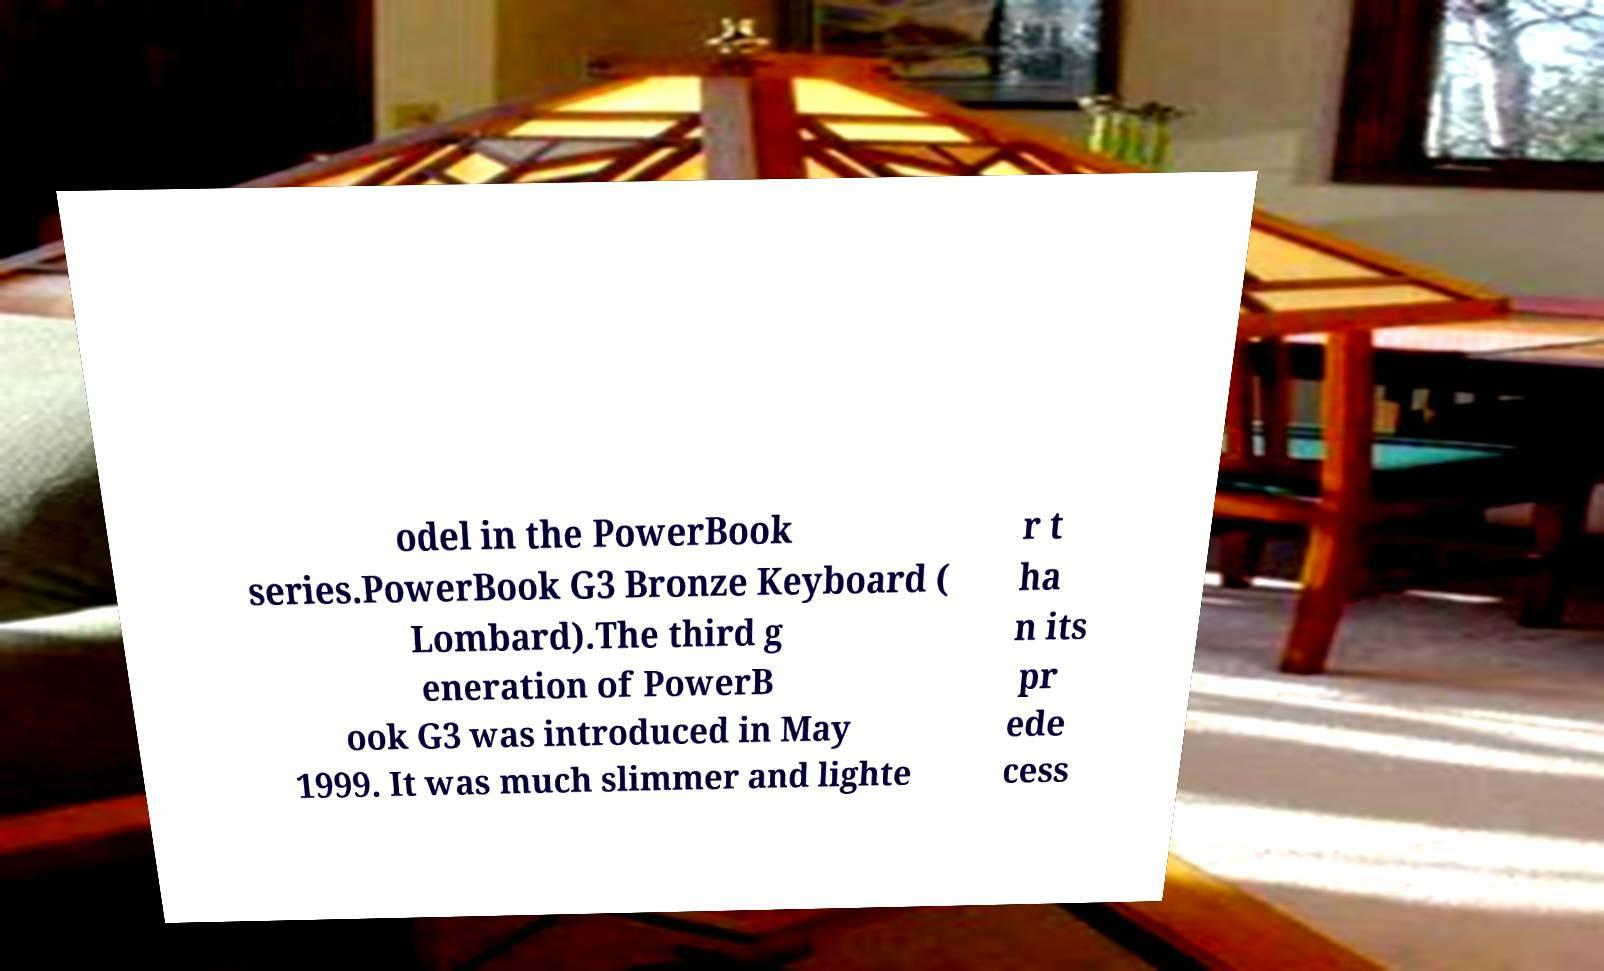I need the written content from this picture converted into text. Can you do that? odel in the PowerBook series.PowerBook G3 Bronze Keyboard ( Lombard).The third g eneration of PowerB ook G3 was introduced in May 1999. It was much slimmer and lighte r t ha n its pr ede cess 